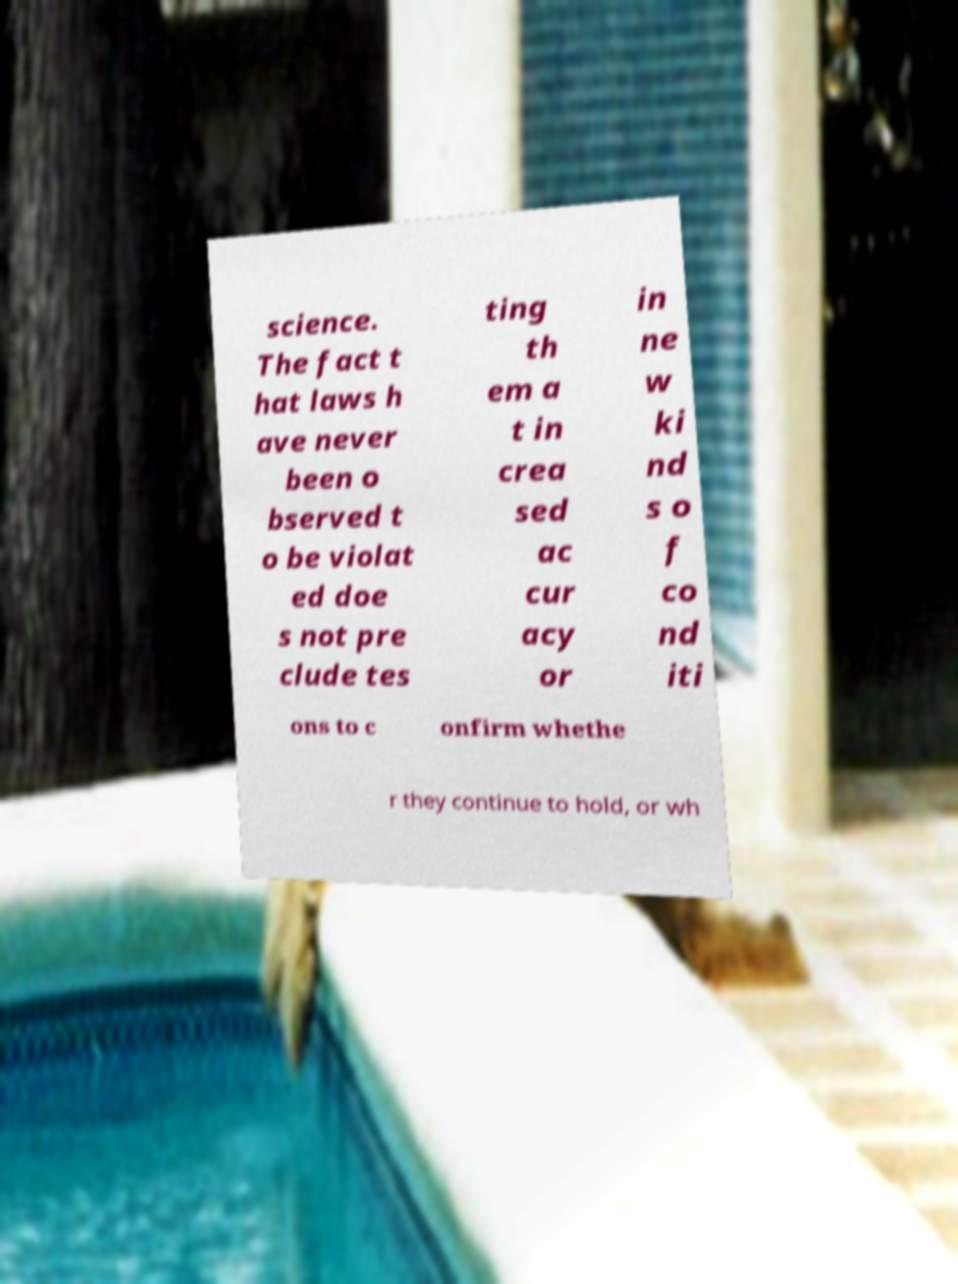For documentation purposes, I need the text within this image transcribed. Could you provide that? science. The fact t hat laws h ave never been o bserved t o be violat ed doe s not pre clude tes ting th em a t in crea sed ac cur acy or in ne w ki nd s o f co nd iti ons to c onfirm whethe r they continue to hold, or wh 